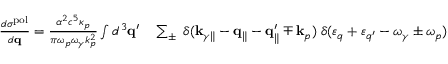<formula> <loc_0><loc_0><loc_500><loc_500>\begin{array} { r l } { \frac { d \sigma ^ { p o l } } { d { q } } = \frac { \alpha ^ { 2 } c ^ { 5 } \kappa _ { p } } { \pi \omega _ { p } \omega _ { \gamma } k _ { p } ^ { 2 } } \int d ^ { 3 } { q } ^ { \prime } } & \sum _ { \pm } \, \delta ( { k } _ { \gamma \| } - { q } _ { \| } - { q } _ { \| } ^ { \prime } \mp { k } _ { p } ) \, \delta ( \varepsilon _ { q } + \varepsilon _ { q ^ { \prime } } - \omega _ { \gamma } \pm \omega _ { p } ) } \end{array}</formula> 